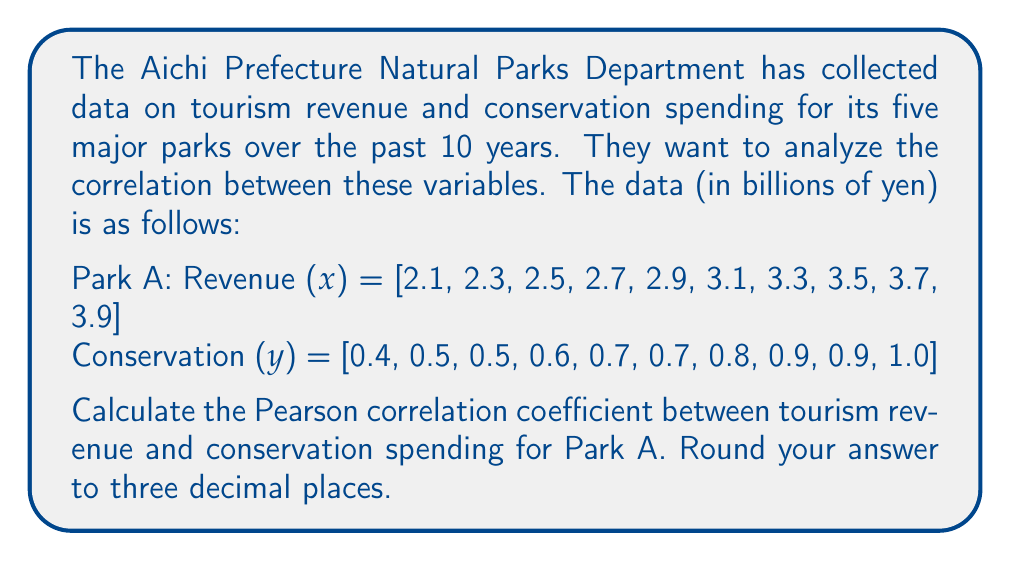Provide a solution to this math problem. To calculate the Pearson correlation coefficient, we'll use the formula:

$$ r = \frac{\sum_{i=1}^{n} (x_i - \bar{x})(y_i - \bar{y})}{\sqrt{\sum_{i=1}^{n} (x_i - \bar{x})^2 \sum_{i=1}^{n} (y_i - \bar{y})^2}} $$

Where:
$r$ is the Pearson correlation coefficient
$x_i$ and $y_i$ are the individual sample points
$\bar{x}$ and $\bar{y}$ are the sample means

Step 1: Calculate the means
$\bar{x} = \frac{2.1 + 2.3 + ... + 3.9}{10} = 3.0$
$\bar{y} = \frac{0.4 + 0.5 + ... + 1.0}{10} = 0.7$

Step 2: Calculate $(x_i - \bar{x})$, $(y_i - \bar{y})$, $(x_i - \bar{x})^2$, $(y_i - \bar{y})^2$, and $(x_i - \bar{x})(y_i - \bar{y})$ for each data point.

Step 3: Sum up the calculated values
$\sum (x_i - \bar{x})(y_i - \bar{y}) = 0.9$
$\sum (x_i - \bar{x})^2 = 3.0$
$\sum (y_i - \bar{y})^2 = 0.3$

Step 4: Apply the formula
$$ r = \frac{0.9}{\sqrt{3.0 \times 0.3}} = \frac{0.9}{\sqrt{0.9}} = \frac{0.9}{0.9487} $$

Step 5: Round to three decimal places
$r \approx 0.949$
Answer: 0.949 